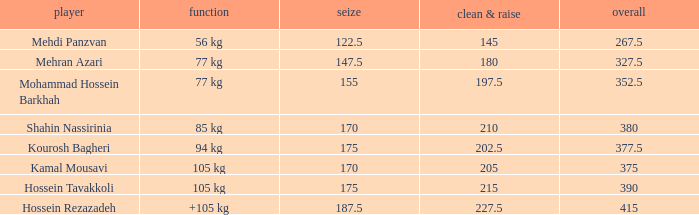What is the total that had an event of +105 kg and clean & jerk less than 227.5? 0.0. 